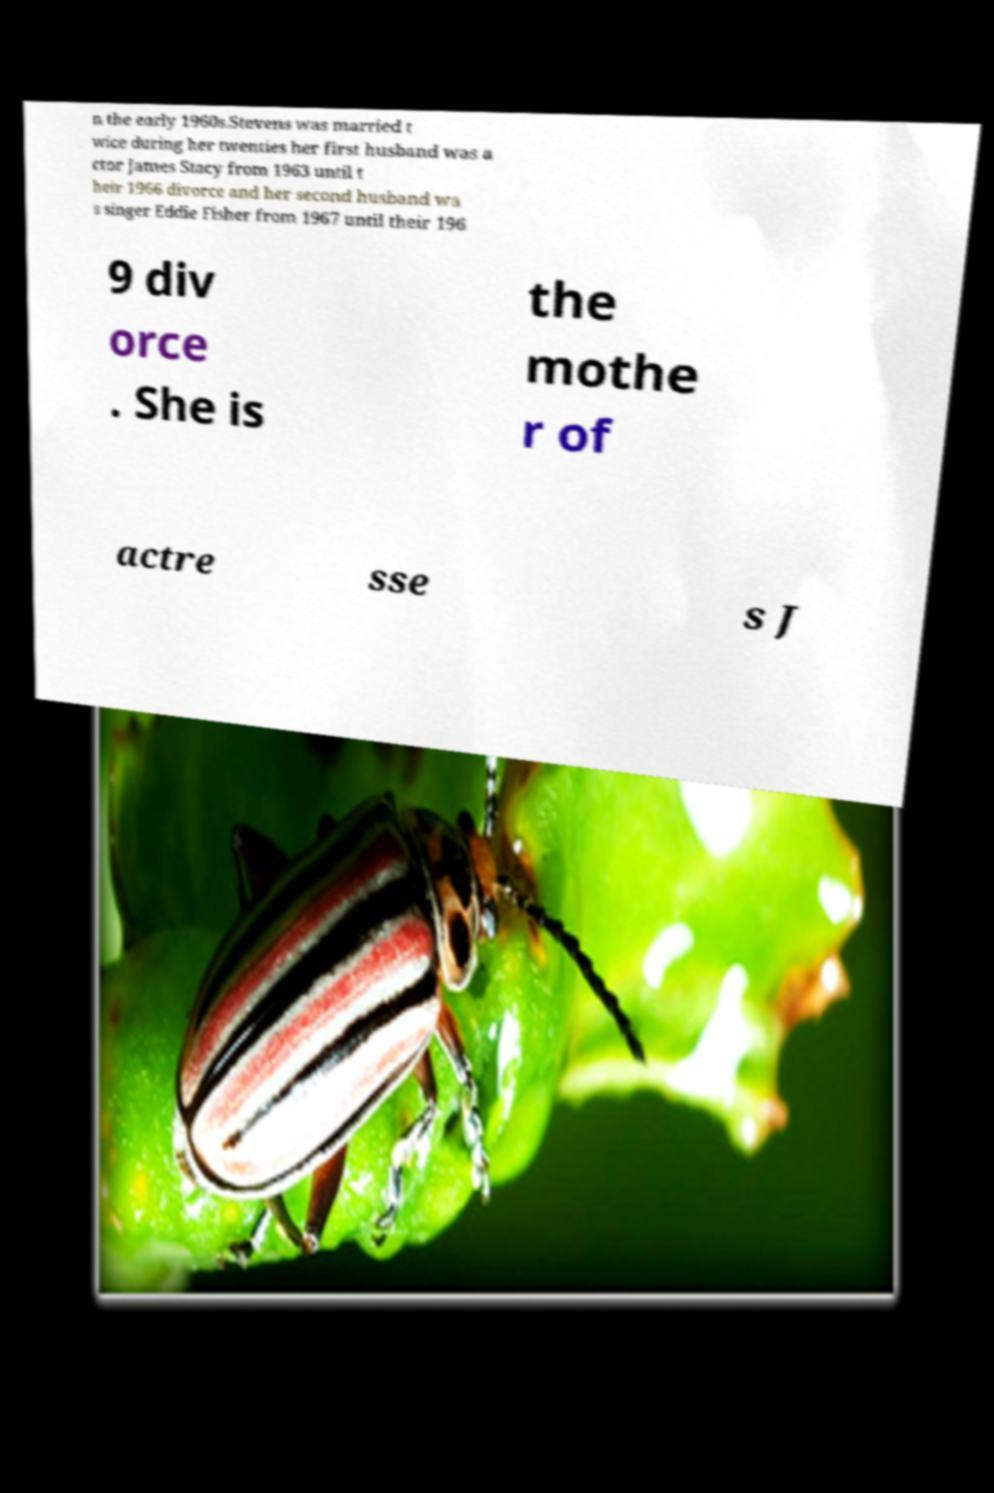For documentation purposes, I need the text within this image transcribed. Could you provide that? n the early 1960s.Stevens was married t wice during her twenties her first husband was a ctor James Stacy from 1963 until t heir 1966 divorce and her second husband wa s singer Eddie Fisher from 1967 until their 196 9 div orce . She is the mothe r of actre sse s J 